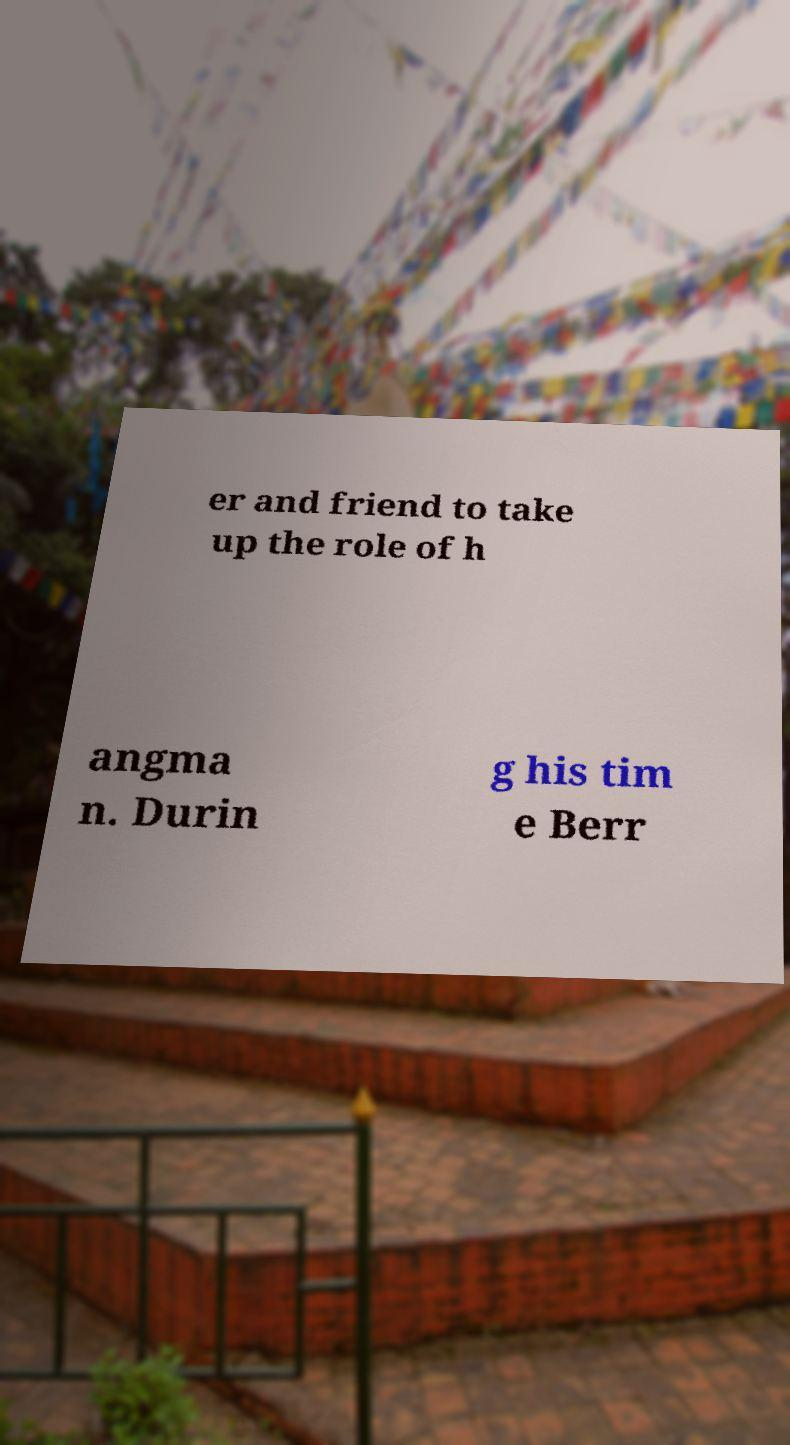Can you read and provide the text displayed in the image?This photo seems to have some interesting text. Can you extract and type it out for me? er and friend to take up the role of h angma n. Durin g his tim e Berr 